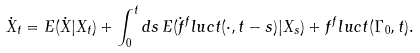<formula> <loc_0><loc_0><loc_500><loc_500>\dot { X } _ { t } = E ( \dot { X } | X _ { t } ) + \int _ { 0 } ^ { t } d s \, E ( \dot { f } ^ { f } l u c t ( \cdot , t - s ) | X _ { s } ) + f ^ { f } l u c t ( \Gamma _ { 0 } , t ) .</formula> 